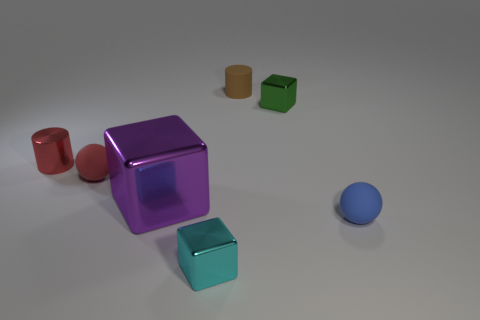Subtract all tiny green blocks. How many blocks are left? 2 Subtract all red spheres. How many spheres are left? 1 Add 2 small balls. How many objects exist? 9 Subtract all balls. How many objects are left? 5 Add 6 large things. How many large things exist? 7 Subtract 0 yellow balls. How many objects are left? 7 Subtract 1 cylinders. How many cylinders are left? 1 Subtract all purple balls. Subtract all purple blocks. How many balls are left? 2 Subtract all small yellow objects. Subtract all rubber cylinders. How many objects are left? 6 Add 1 big blocks. How many big blocks are left? 2 